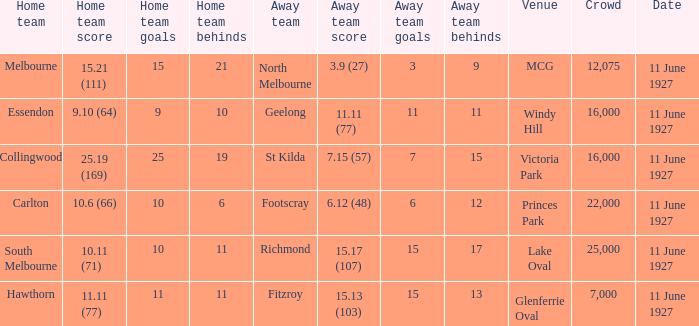Which domestic team faced off against the visiting team geelong? Essendon. Parse the full table. {'header': ['Home team', 'Home team score', 'Home team goals', 'Home team behinds', 'Away team', 'Away team score', 'Away team goals', 'Away team behinds', 'Venue', 'Crowd', 'Date'], 'rows': [['Melbourne', '15.21 (111)', '15', '21', 'North Melbourne', '3.9 (27)', '3', '9', 'MCG', '12,075', '11 June 1927'], ['Essendon', '9.10 (64)', '9', '10', 'Geelong', '11.11 (77)', '11', '11', 'Windy Hill', '16,000', '11 June 1927'], ['Collingwood', '25.19 (169)', '25', '19', 'St Kilda', '7.15 (57)', '7', '15', 'Victoria Park', '16,000', '11 June 1927'], ['Carlton', '10.6 (66)', '10', '6', 'Footscray', '6.12 (48)', '6', '12', 'Princes Park', '22,000', '11 June 1927'], ['South Melbourne', '10.11 (71)', '10', '11', 'Richmond', '15.17 (107)', '15', '17', 'Lake Oval', '25,000', '11 June 1927'], ['Hawthorn', '11.11 (77)', '11', '11', 'Fitzroy', '15.13 (103)', '15', '13', 'Glenferrie Oval', '7,000', '11 June 1927']]} 